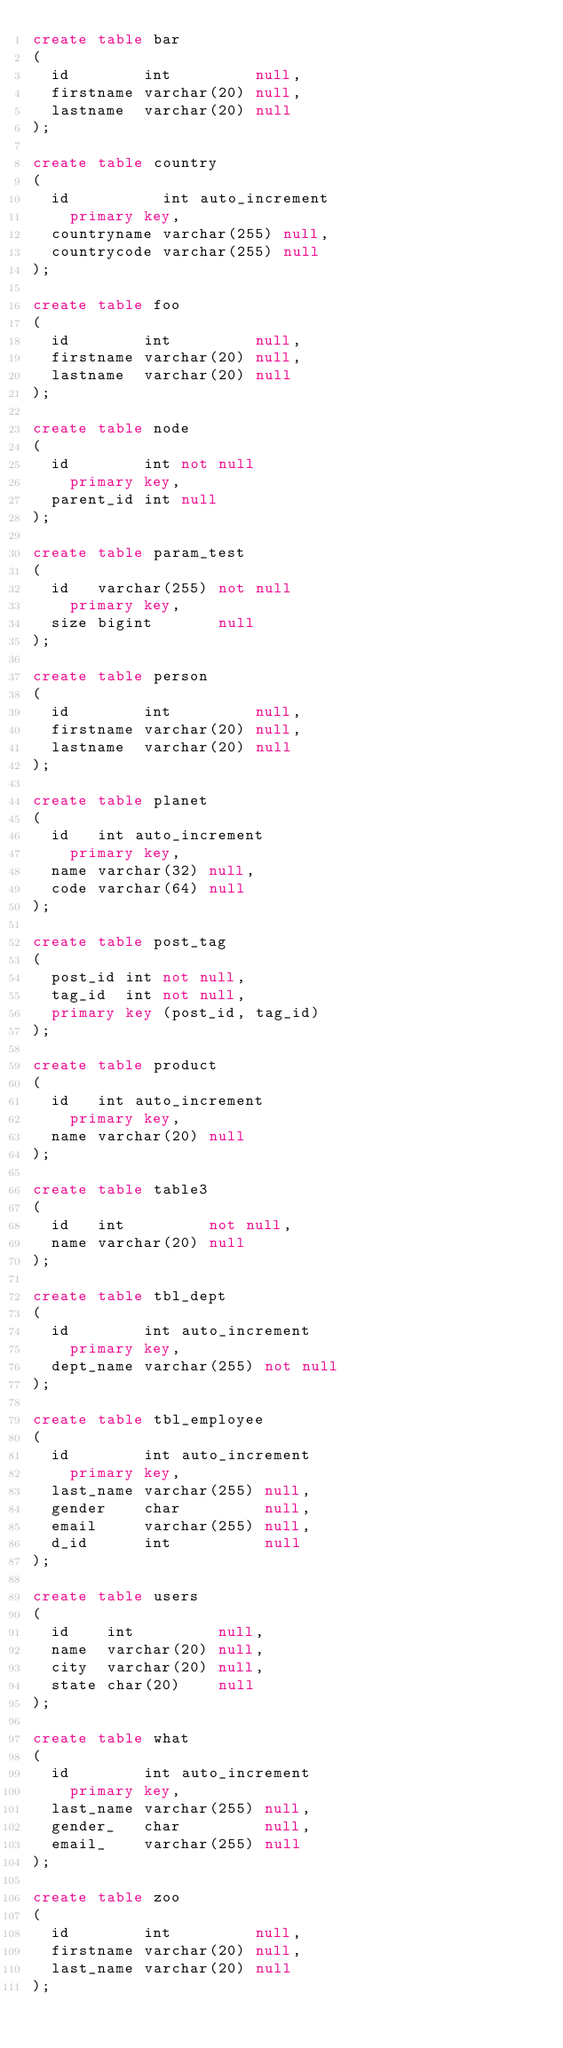Convert code to text. <code><loc_0><loc_0><loc_500><loc_500><_SQL_>create table bar
(
  id        int         null,
  firstname varchar(20) null,
  lastname  varchar(20) null
);

create table country
(
  id          int auto_increment
    primary key,
  countryname varchar(255) null,
  countrycode varchar(255) null
);

create table foo
(
  id        int         null,
  firstname varchar(20) null,
  lastname  varchar(20) null
);

create table node
(
  id        int not null
    primary key,
  parent_id int null
);

create table param_test
(
  id   varchar(255) not null
    primary key,
  size bigint       null
);

create table person
(
  id        int         null,
  firstname varchar(20) null,
  lastname  varchar(20) null
);

create table planet
(
  id   int auto_increment
    primary key,
  name varchar(32) null,
  code varchar(64) null
);

create table post_tag
(
  post_id int not null,
  tag_id  int not null,
  primary key (post_id, tag_id)
);

create table product
(
  id   int auto_increment
    primary key,
  name varchar(20) null
);

create table table3
(
  id   int         not null,
  name varchar(20) null
);

create table tbl_dept
(
  id        int auto_increment
    primary key,
  dept_name varchar(255) not null
);

create table tbl_employee
(
  id        int auto_increment
    primary key,
  last_name varchar(255) null,
  gender    char         null,
  email     varchar(255) null,
  d_id      int          null
);

create table users
(
  id    int         null,
  name  varchar(20) null,
  city  varchar(20) null,
  state char(20)    null
);

create table what
(
  id        int auto_increment
    primary key,
  last_name varchar(255) null,
  gender_   char         null,
  email_    varchar(255) null
);

create table zoo
(
  id        int         null,
  firstname varchar(20) null,
  last_name varchar(20) null
);

</code> 